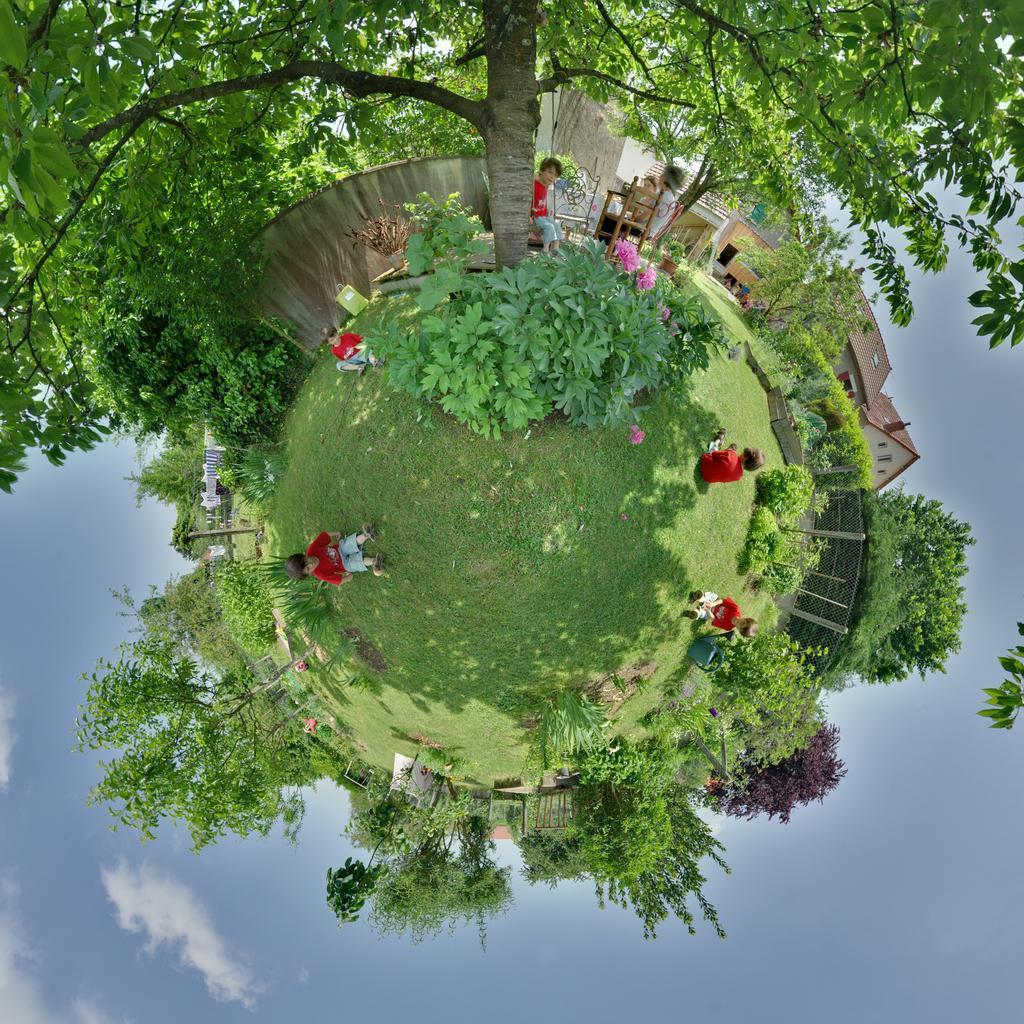Describe this image in one or two sentences. In this image at the center children are sitting on the surface of the grass. Behind them there are two persons sitting on the chairs. In the background there are trees, building and sky. 